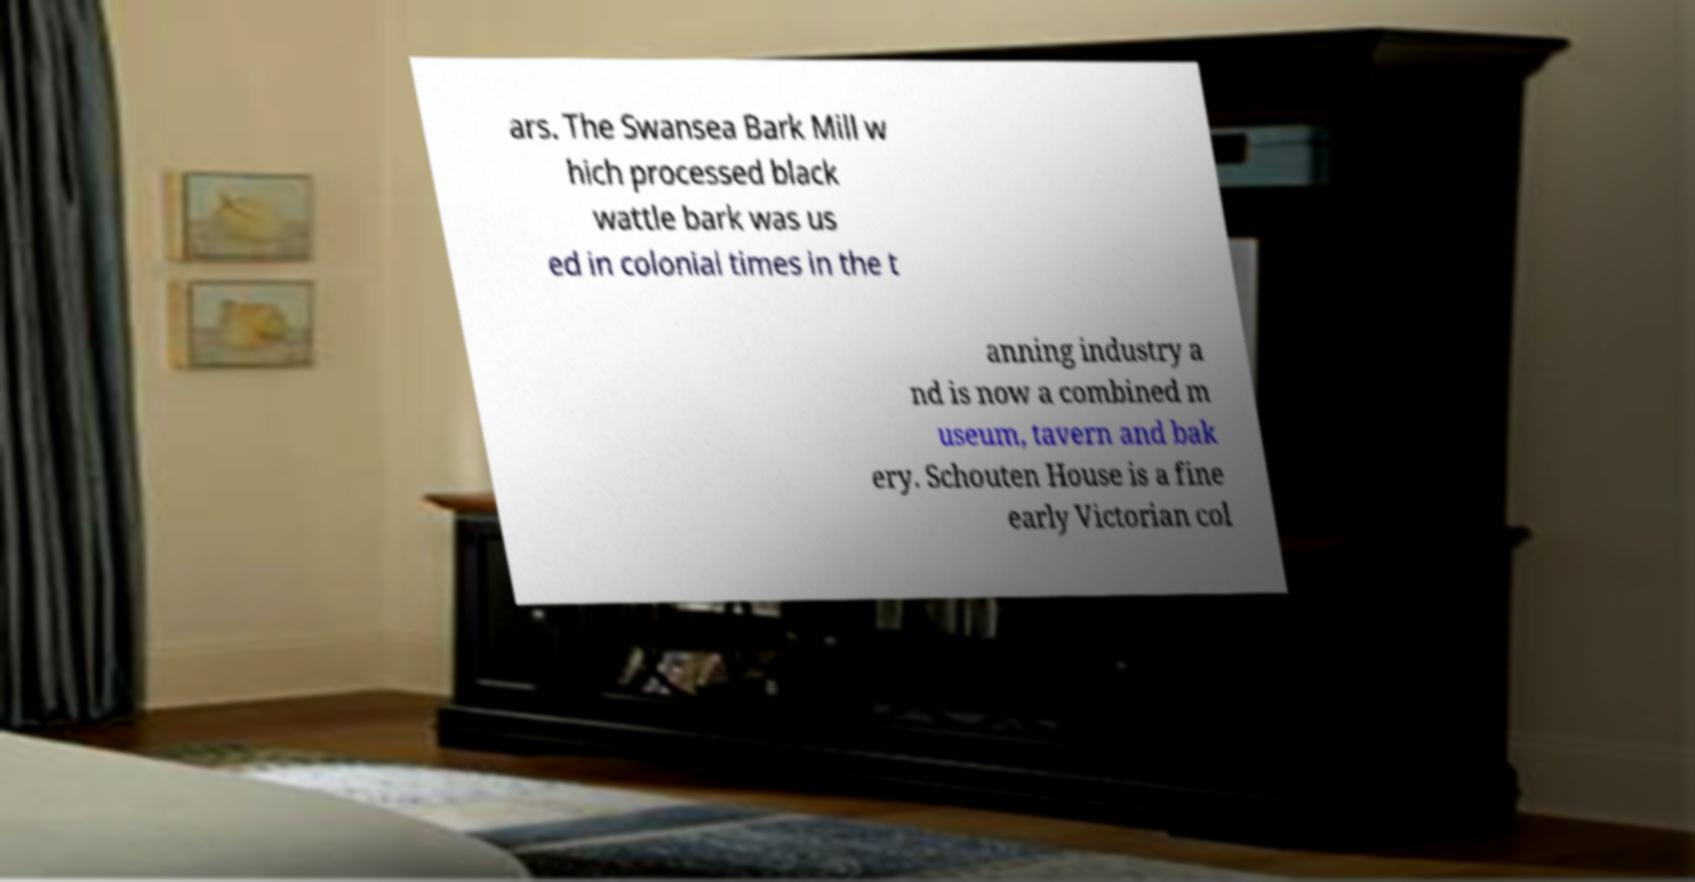I need the written content from this picture converted into text. Can you do that? ars. The Swansea Bark Mill w hich processed black wattle bark was us ed in colonial times in the t anning industry a nd is now a combined m useum, tavern and bak ery. Schouten House is a fine early Victorian col 